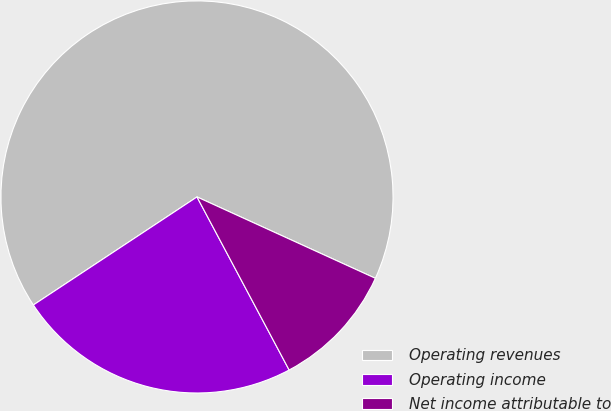<chart> <loc_0><loc_0><loc_500><loc_500><pie_chart><fcel>Operating revenues<fcel>Operating income<fcel>Net income attributable to<nl><fcel>66.1%<fcel>23.5%<fcel>10.4%<nl></chart> 